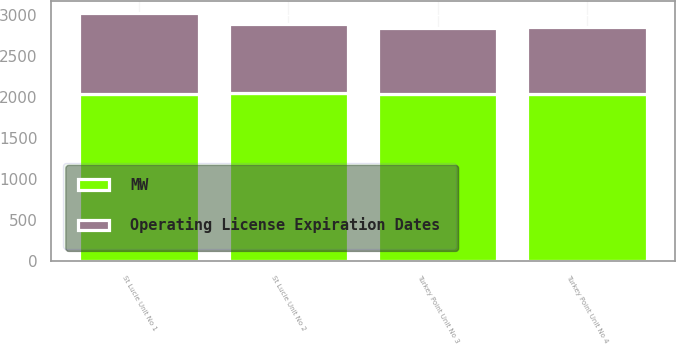Convert chart to OTSL. <chart><loc_0><loc_0><loc_500><loc_500><stacked_bar_chart><ecel><fcel>St Lucie Unit No 1<fcel>St Lucie Unit No 2<fcel>Turkey Point Unit No 3<fcel>Turkey Point Unit No 4<nl><fcel>Operating License Expiration Dates<fcel>981<fcel>840<fcel>811<fcel>821<nl><fcel>MW<fcel>2036<fcel>2043<fcel>2032<fcel>2033<nl></chart> 